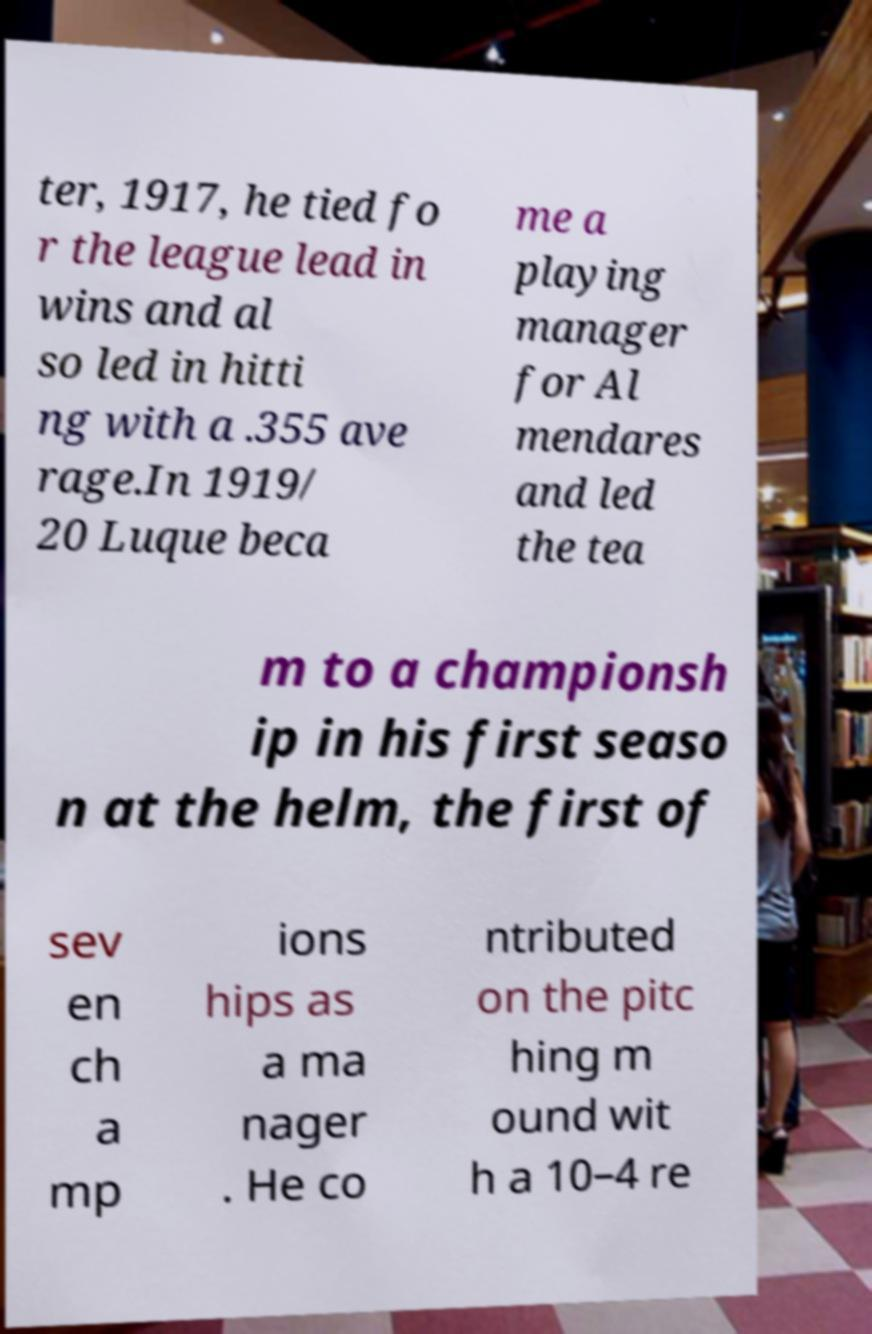Please read and relay the text visible in this image. What does it say? ter, 1917, he tied fo r the league lead in wins and al so led in hitti ng with a .355 ave rage.In 1919/ 20 Luque beca me a playing manager for Al mendares and led the tea m to a championsh ip in his first seaso n at the helm, the first of sev en ch a mp ions hips as a ma nager . He co ntributed on the pitc hing m ound wit h a 10–4 re 